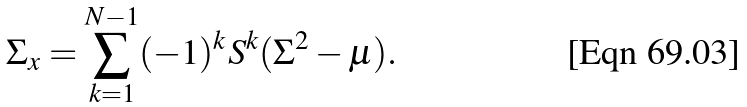Convert formula to latex. <formula><loc_0><loc_0><loc_500><loc_500>\Sigma _ { x } = \sum _ { k = 1 } ^ { N - 1 } ( - 1 ) ^ { k } S ^ { k } ( \Sigma ^ { 2 } - \mu ) .</formula> 